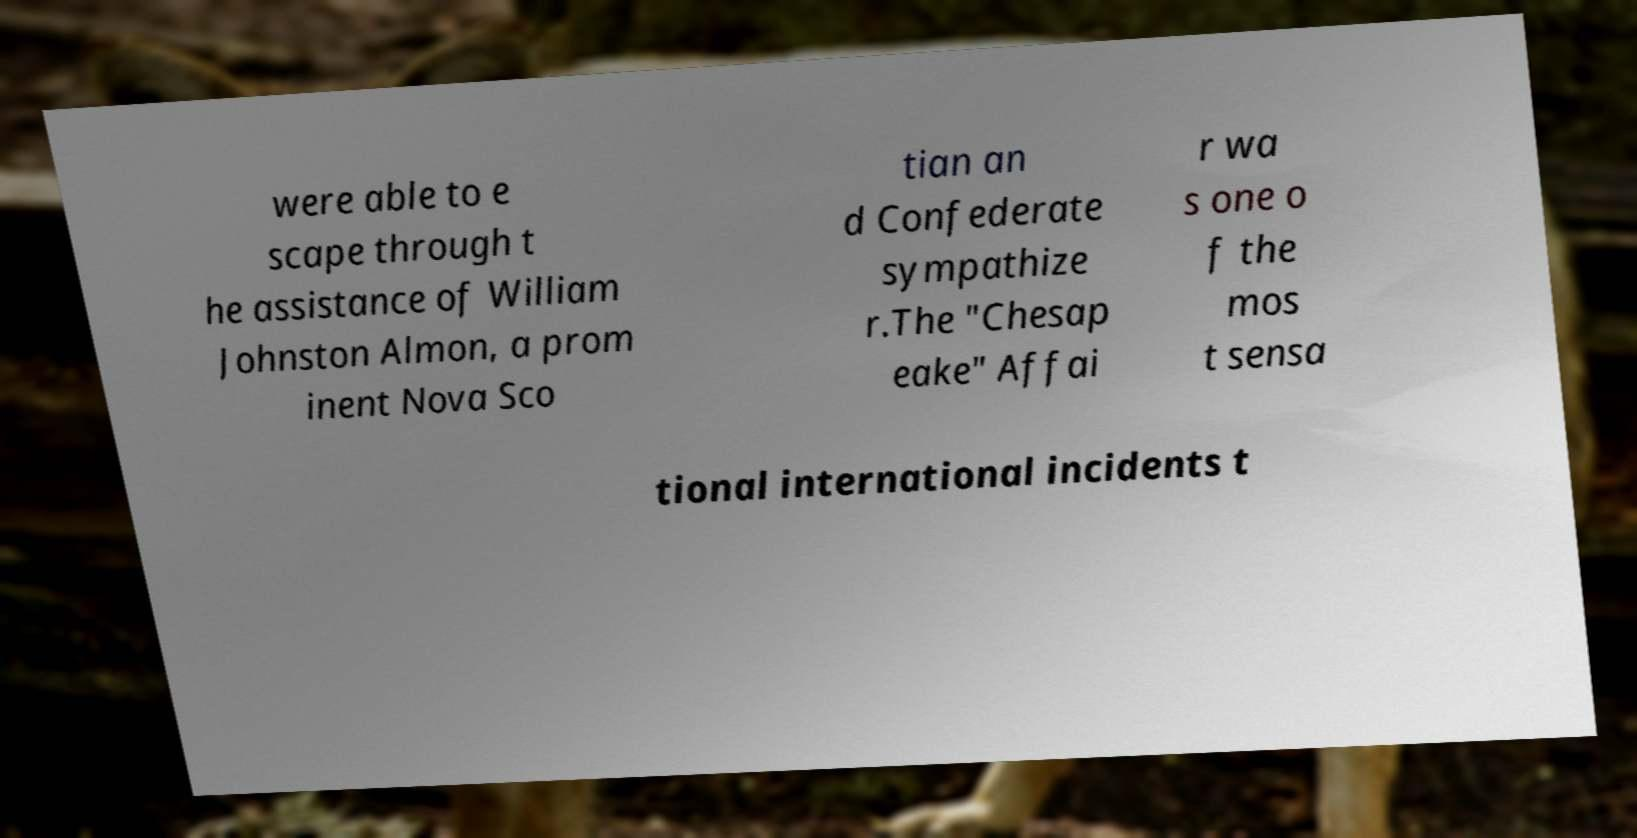I need the written content from this picture converted into text. Can you do that? were able to e scape through t he assistance of William Johnston Almon, a prom inent Nova Sco tian an d Confederate sympathize r.The "Chesap eake" Affai r wa s one o f the mos t sensa tional international incidents t 